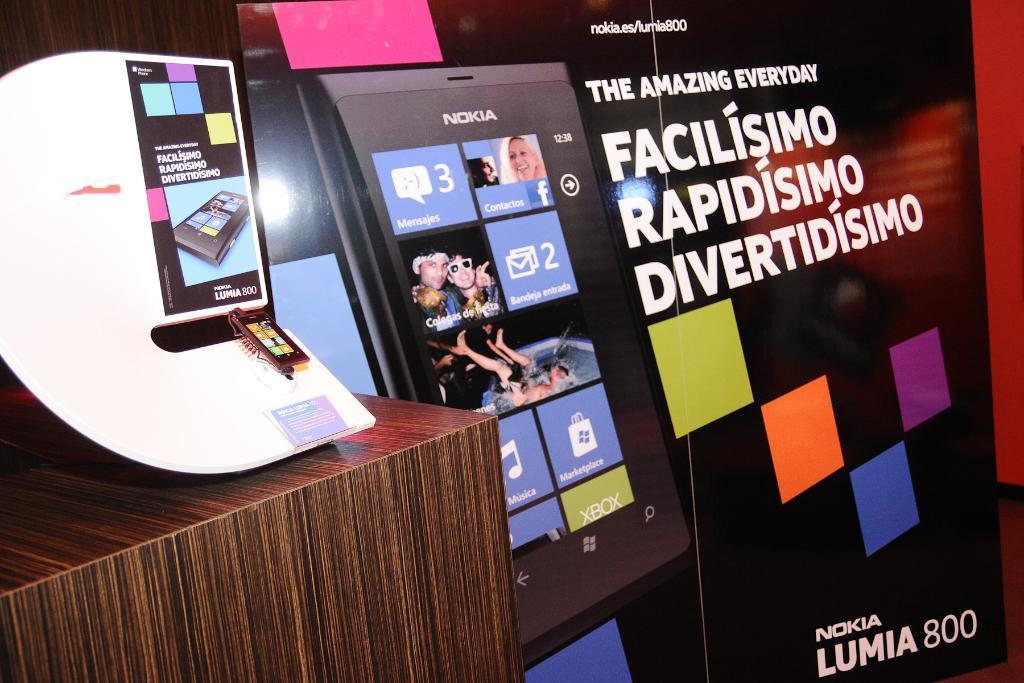Provide a one-sentence caption for the provided image. ad poster for the nokia lumia 800 cell phone. 